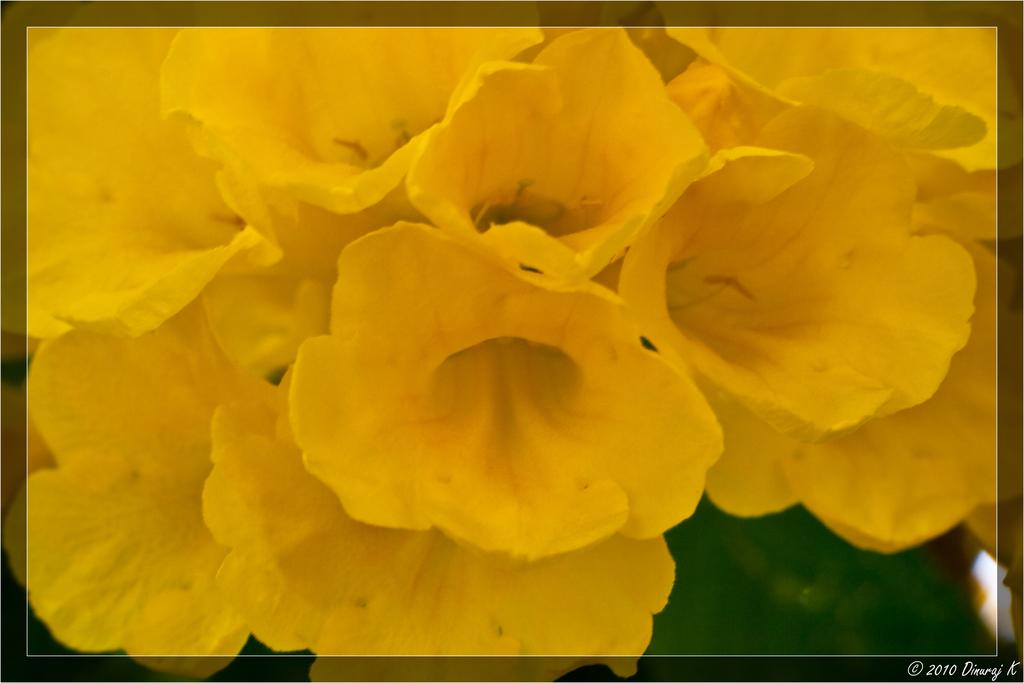What type of flowers are present in the image? There are yellow flowers in the image. Where can the text be found in the image? The text is located in the bottom right corner of the image. What type of wire is being used to hold the toy car in the image? There is no wire or toy car present in the image; it only features yellow flowers and text in the bottom right corner. 